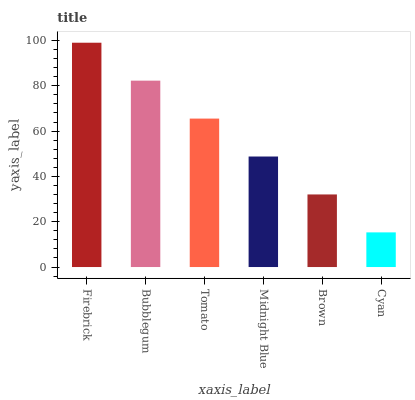Is Cyan the minimum?
Answer yes or no. Yes. Is Firebrick the maximum?
Answer yes or no. Yes. Is Bubblegum the minimum?
Answer yes or no. No. Is Bubblegum the maximum?
Answer yes or no. No. Is Firebrick greater than Bubblegum?
Answer yes or no. Yes. Is Bubblegum less than Firebrick?
Answer yes or no. Yes. Is Bubblegum greater than Firebrick?
Answer yes or no. No. Is Firebrick less than Bubblegum?
Answer yes or no. No. Is Tomato the high median?
Answer yes or no. Yes. Is Midnight Blue the low median?
Answer yes or no. Yes. Is Cyan the high median?
Answer yes or no. No. Is Cyan the low median?
Answer yes or no. No. 